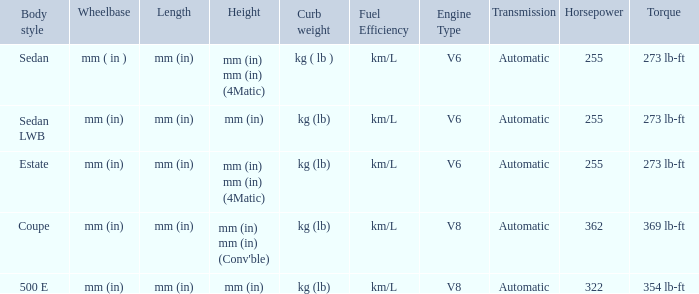What are the lengths of the models that are mm (in) tall? Mm (in), mm (in). 